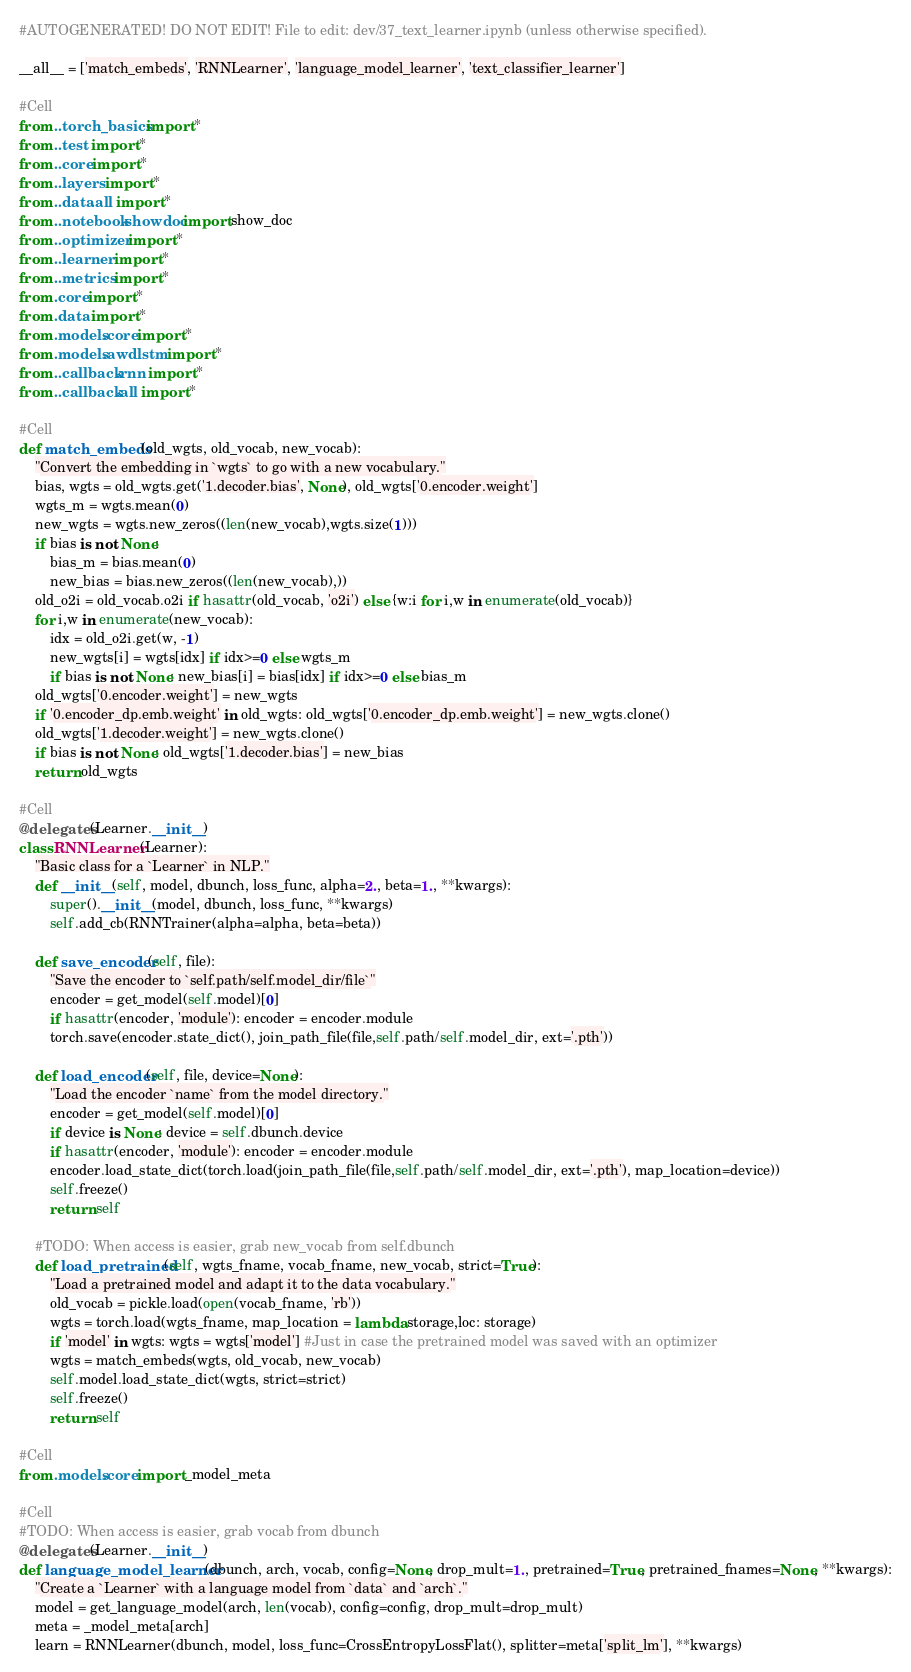<code> <loc_0><loc_0><loc_500><loc_500><_Python_>#AUTOGENERATED! DO NOT EDIT! File to edit: dev/37_text_learner.ipynb (unless otherwise specified).

__all__ = ['match_embeds', 'RNNLearner', 'language_model_learner', 'text_classifier_learner']

#Cell
from ..torch_basics import *
from ..test import *
from ..core import *
from ..layers import *
from ..data.all import *
from ..notebook.showdoc import show_doc
from ..optimizer import *
from ..learner import *
from ..metrics import *
from .core import *
from .data import *
from .models.core import *
from .models.awdlstm import *
from ..callback.rnn import *
from ..callback.all import *

#Cell
def match_embeds(old_wgts, old_vocab, new_vocab):
    "Convert the embedding in `wgts` to go with a new vocabulary."
    bias, wgts = old_wgts.get('1.decoder.bias', None), old_wgts['0.encoder.weight']
    wgts_m = wgts.mean(0)
    new_wgts = wgts.new_zeros((len(new_vocab),wgts.size(1)))
    if bias is not None:
        bias_m = bias.mean(0)
        new_bias = bias.new_zeros((len(new_vocab),))
    old_o2i = old_vocab.o2i if hasattr(old_vocab, 'o2i') else {w:i for i,w in enumerate(old_vocab)}
    for i,w in enumerate(new_vocab):
        idx = old_o2i.get(w, -1)
        new_wgts[i] = wgts[idx] if idx>=0 else wgts_m
        if bias is not None: new_bias[i] = bias[idx] if idx>=0 else bias_m
    old_wgts['0.encoder.weight'] = new_wgts
    if '0.encoder_dp.emb.weight' in old_wgts: old_wgts['0.encoder_dp.emb.weight'] = new_wgts.clone()
    old_wgts['1.decoder.weight'] = new_wgts.clone()
    if bias is not None: old_wgts['1.decoder.bias'] = new_bias
    return old_wgts

#Cell
@delegates(Learner.__init__)
class RNNLearner(Learner):
    "Basic class for a `Learner` in NLP."
    def __init__(self, model, dbunch, loss_func, alpha=2., beta=1., **kwargs):
        super().__init__(model, dbunch, loss_func, **kwargs)
        self.add_cb(RNNTrainer(alpha=alpha, beta=beta))

    def save_encoder(self, file):
        "Save the encoder to `self.path/self.model_dir/file`"
        encoder = get_model(self.model)[0]
        if hasattr(encoder, 'module'): encoder = encoder.module
        torch.save(encoder.state_dict(), join_path_file(file,self.path/self.model_dir, ext='.pth'))

    def load_encoder(self, file, device=None):
        "Load the encoder `name` from the model directory."
        encoder = get_model(self.model)[0]
        if device is None: device = self.dbunch.device
        if hasattr(encoder, 'module'): encoder = encoder.module
        encoder.load_state_dict(torch.load(join_path_file(file,self.path/self.model_dir, ext='.pth'), map_location=device))
        self.freeze()
        return self

    #TODO: When access is easier, grab new_vocab from self.dbunch
    def load_pretrained(self, wgts_fname, vocab_fname, new_vocab, strict=True):
        "Load a pretrained model and adapt it to the data vocabulary."
        old_vocab = pickle.load(open(vocab_fname, 'rb'))
        wgts = torch.load(wgts_fname, map_location = lambda storage,loc: storage)
        if 'model' in wgts: wgts = wgts['model'] #Just in case the pretrained model was saved with an optimizer
        wgts = match_embeds(wgts, old_vocab, new_vocab)
        self.model.load_state_dict(wgts, strict=strict)
        self.freeze()
        return self

#Cell
from .models.core import _model_meta

#Cell
#TODO: When access is easier, grab vocab from dbunch
@delegates(Learner.__init__)
def language_model_learner(dbunch, arch, vocab, config=None, drop_mult=1., pretrained=True, pretrained_fnames=None, **kwargs):
    "Create a `Learner` with a language model from `data` and `arch`."
    model = get_language_model(arch, len(vocab), config=config, drop_mult=drop_mult)
    meta = _model_meta[arch]
    learn = RNNLearner(dbunch, model, loss_func=CrossEntropyLossFlat(), splitter=meta['split_lm'], **kwargs)</code> 